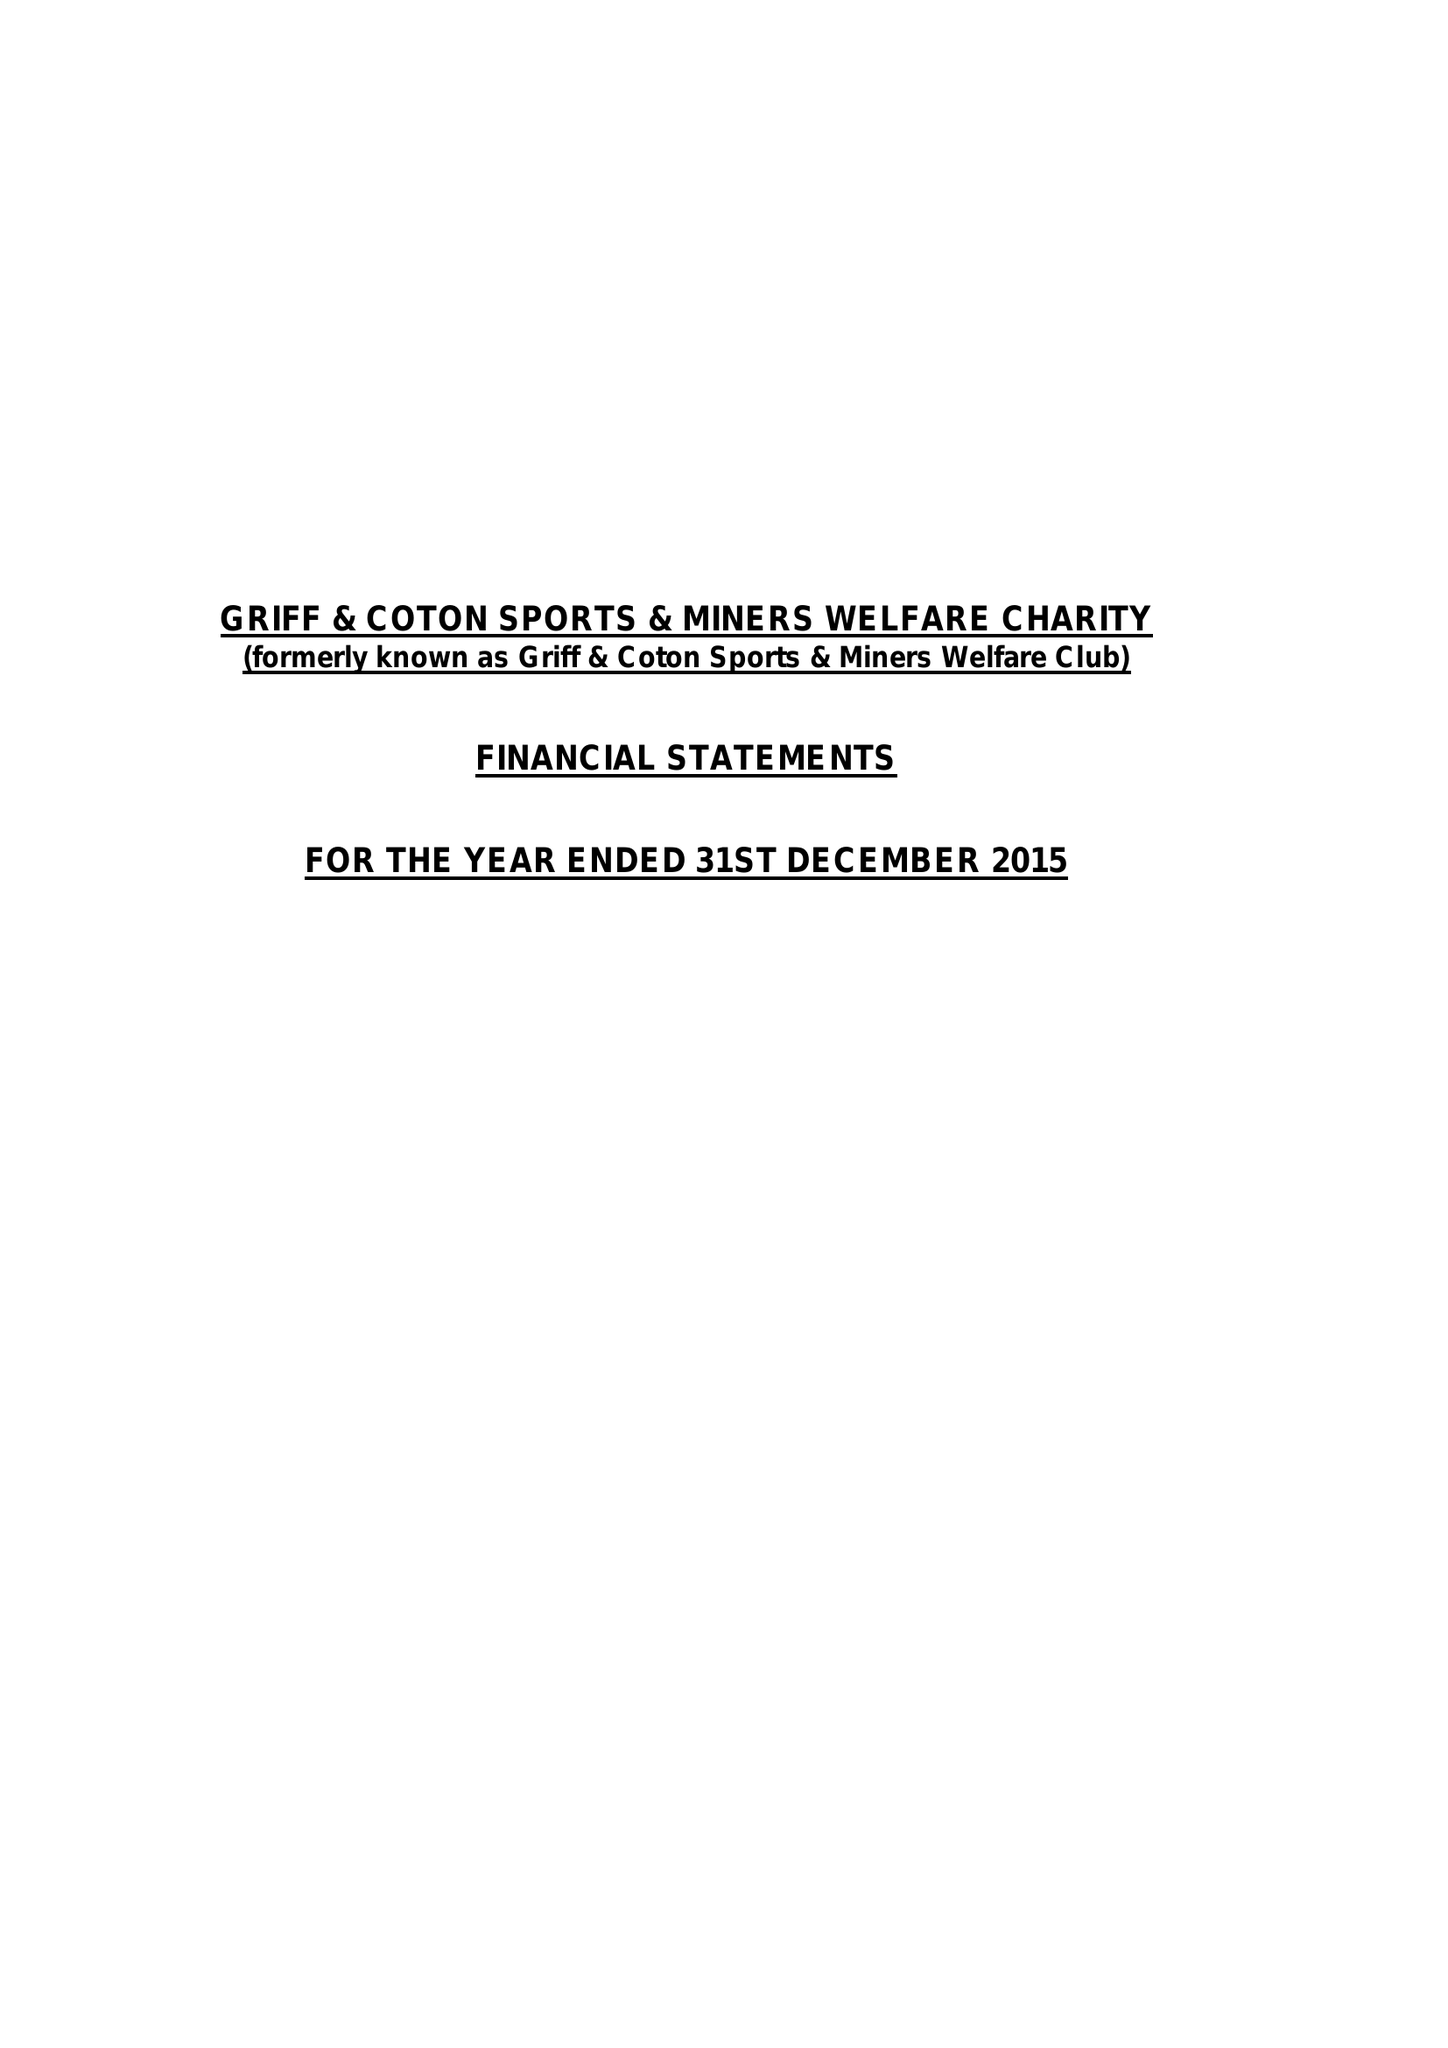What is the value for the income_annually_in_british_pounds?
Answer the question using a single word or phrase. 143588.00 